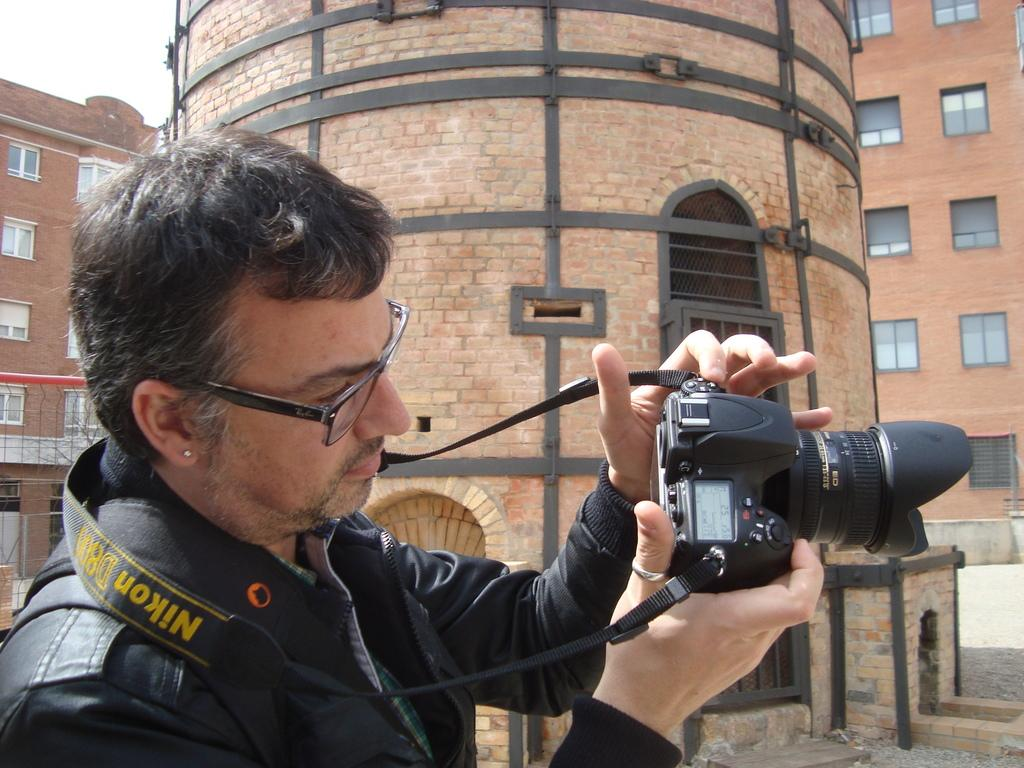Who is present in the image? There is a man in the image. What is the man wearing on his face? The man is wearing spectacles. What type of clothing is the man wearing on his upper body? The man is wearing a black jacket. What is the man holding in his hands? The man is holding a camera. What can be seen in the background of the image? There is a building in the background of the image. What is the building made of? The building has bricks. How many openings can be seen on the building? The building has many windows. What type of paper is the man holding in his ear in the image? There is no paper present in the image, nor is the man holding anything in his ear. 